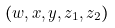<formula> <loc_0><loc_0><loc_500><loc_500>( w , x , y , z _ { 1 } , z _ { 2 } )</formula> 